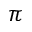Convert formula to latex. <formula><loc_0><loc_0><loc_500><loc_500>\pi</formula> 